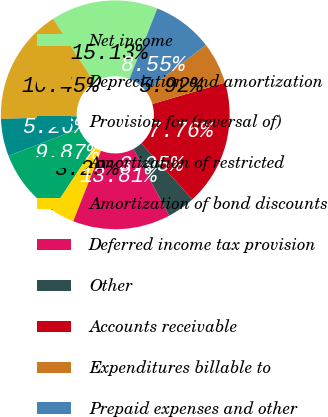Convert chart. <chart><loc_0><loc_0><loc_500><loc_500><pie_chart><fcel>Net income<fcel>Depreciation and amortization<fcel>Provision for (reversal of)<fcel>Amortization of restricted<fcel>Amortization of bond discounts<fcel>Deferred income tax provision<fcel>Other<fcel>Accounts receivable<fcel>Expenditures billable to<fcel>Prepaid expenses and other<nl><fcel>15.13%<fcel>16.45%<fcel>5.26%<fcel>9.87%<fcel>3.29%<fcel>13.81%<fcel>3.95%<fcel>17.76%<fcel>5.92%<fcel>8.55%<nl></chart> 